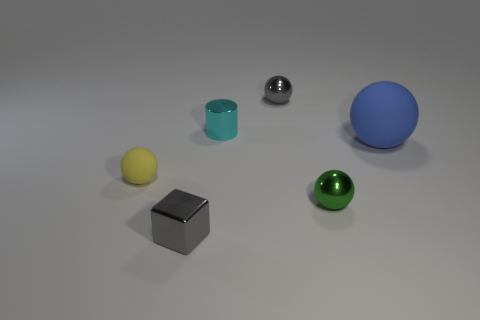Add 4 balls. How many objects exist? 10 Subtract all cylinders. How many objects are left? 5 Subtract all large blue rubber balls. Subtract all blue rubber objects. How many objects are left? 4 Add 1 yellow rubber things. How many yellow rubber things are left? 2 Add 6 large gray cylinders. How many large gray cylinders exist? 6 Subtract 0 red cylinders. How many objects are left? 6 